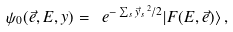Convert formula to latex. <formula><loc_0><loc_0><loc_500><loc_500>\psi _ { 0 } ( \vec { e } , E , y ) = \ e ^ { - \sum _ { s } \vec { y } _ { s } { \, } ^ { 2 } / 2 } | F ( E , \vec { e } ) \rangle \, ,</formula> 